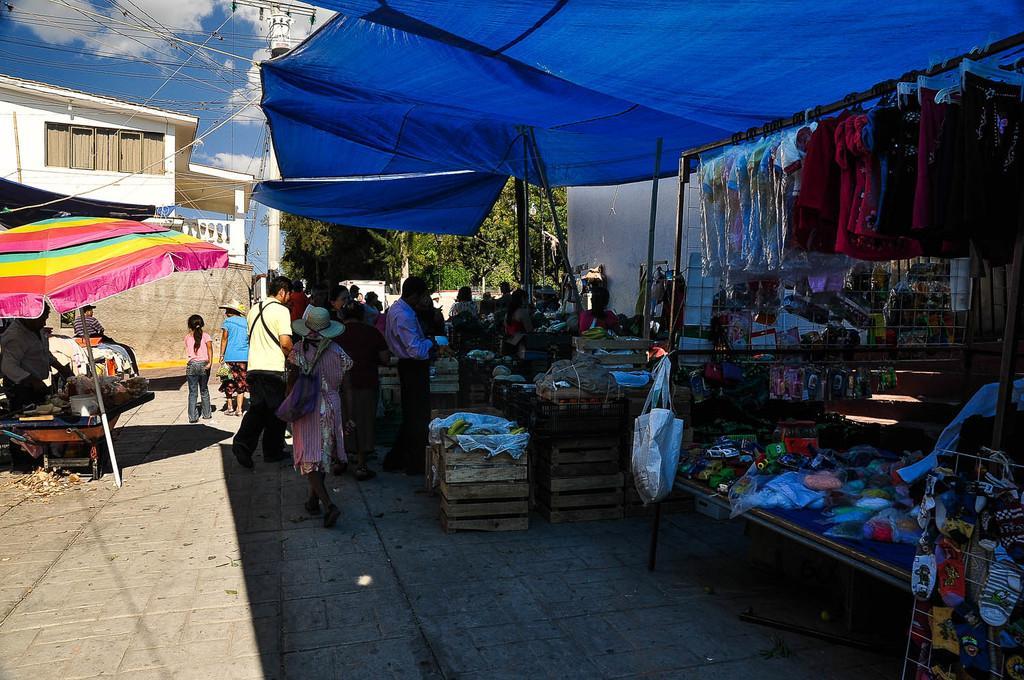How would you summarize this image in a sentence or two? This is the picture of a place where we have some things on the tables and some clothes hanged to the pole and around there are some houses, people and a umbrella. 